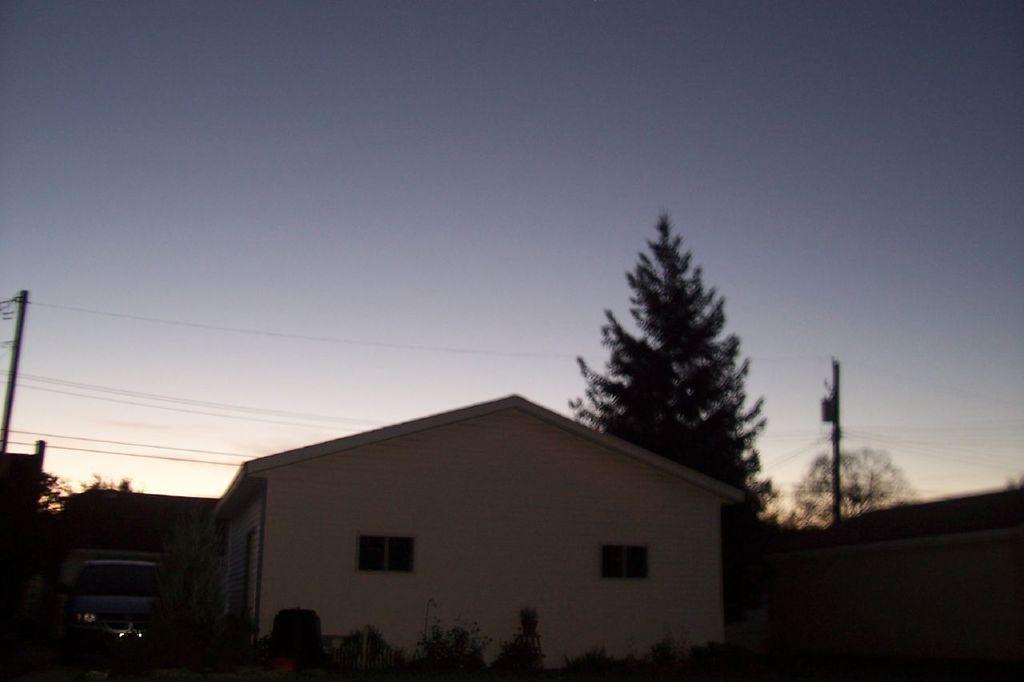How would you summarize this image in a sentence or two? In the image there is a building in the front with a car left side of it, behind it there are trees and electric poles and above its sky. 